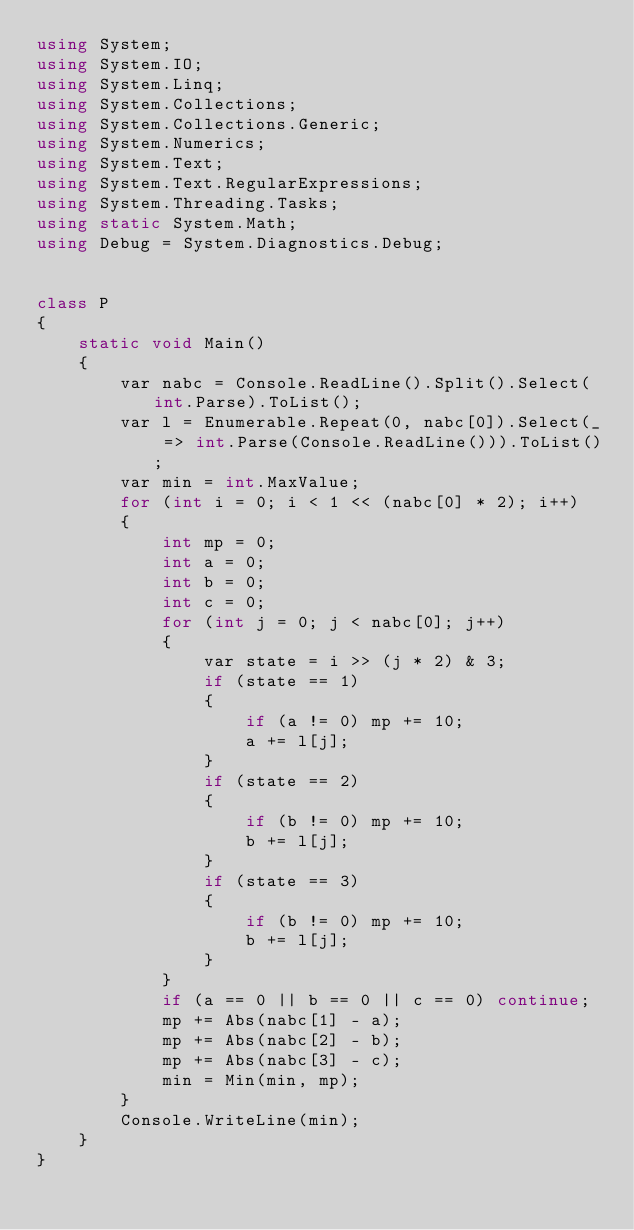<code> <loc_0><loc_0><loc_500><loc_500><_C#_>using System;
using System.IO;
using System.Linq;
using System.Collections;
using System.Collections.Generic;
using System.Numerics;
using System.Text;
using System.Text.RegularExpressions;
using System.Threading.Tasks;
using static System.Math;
using Debug = System.Diagnostics.Debug;


class P
{
    static void Main()
    {
        var nabc = Console.ReadLine().Split().Select(int.Parse).ToList();
        var l = Enumerable.Repeat(0, nabc[0]).Select(_ => int.Parse(Console.ReadLine())).ToList();
        var min = int.MaxValue;
        for (int i = 0; i < 1 << (nabc[0] * 2); i++)
        {
            int mp = 0;
            int a = 0;
            int b = 0;
            int c = 0;
            for (int j = 0; j < nabc[0]; j++)
            {
                var state = i >> (j * 2) & 3;
                if (state == 1)
                {
                    if (a != 0) mp += 10;
                    a += l[j];
                }
                if (state == 2)
                {
                    if (b != 0) mp += 10;
                    b += l[j];
                }
                if (state == 3)
                {
                    if (b != 0) mp += 10;
                    b += l[j];
                }
            }
            if (a == 0 || b == 0 || c == 0) continue;
            mp += Abs(nabc[1] - a);
            mp += Abs(nabc[2] - b);
            mp += Abs(nabc[3] - c);
            min = Min(min, mp);
        }
        Console.WriteLine(min);
    }
}
</code> 